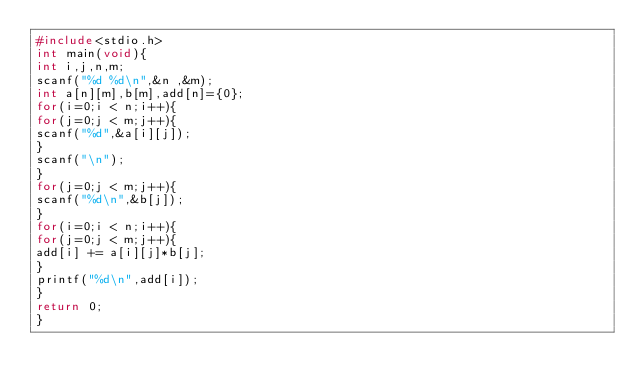<code> <loc_0><loc_0><loc_500><loc_500><_C_>#include<stdio.h>
int main(void){
int i,j,n,m;
scanf("%d %d\n",&n ,&m);
int a[n][m],b[m],add[n]={0};
for(i=0;i < n;i++){
for(j=0;j < m;j++){
scanf("%d",&a[i][j]);
}
scanf("\n");
}
for(j=0;j < m;j++){
scanf("%d\n",&b[j]);
}
for(i=0;i < n;i++){
for(j=0;j < m;j++){
add[i] += a[i][j]*b[j];
}
printf("%d\n",add[i]);
}
return 0;
}</code> 